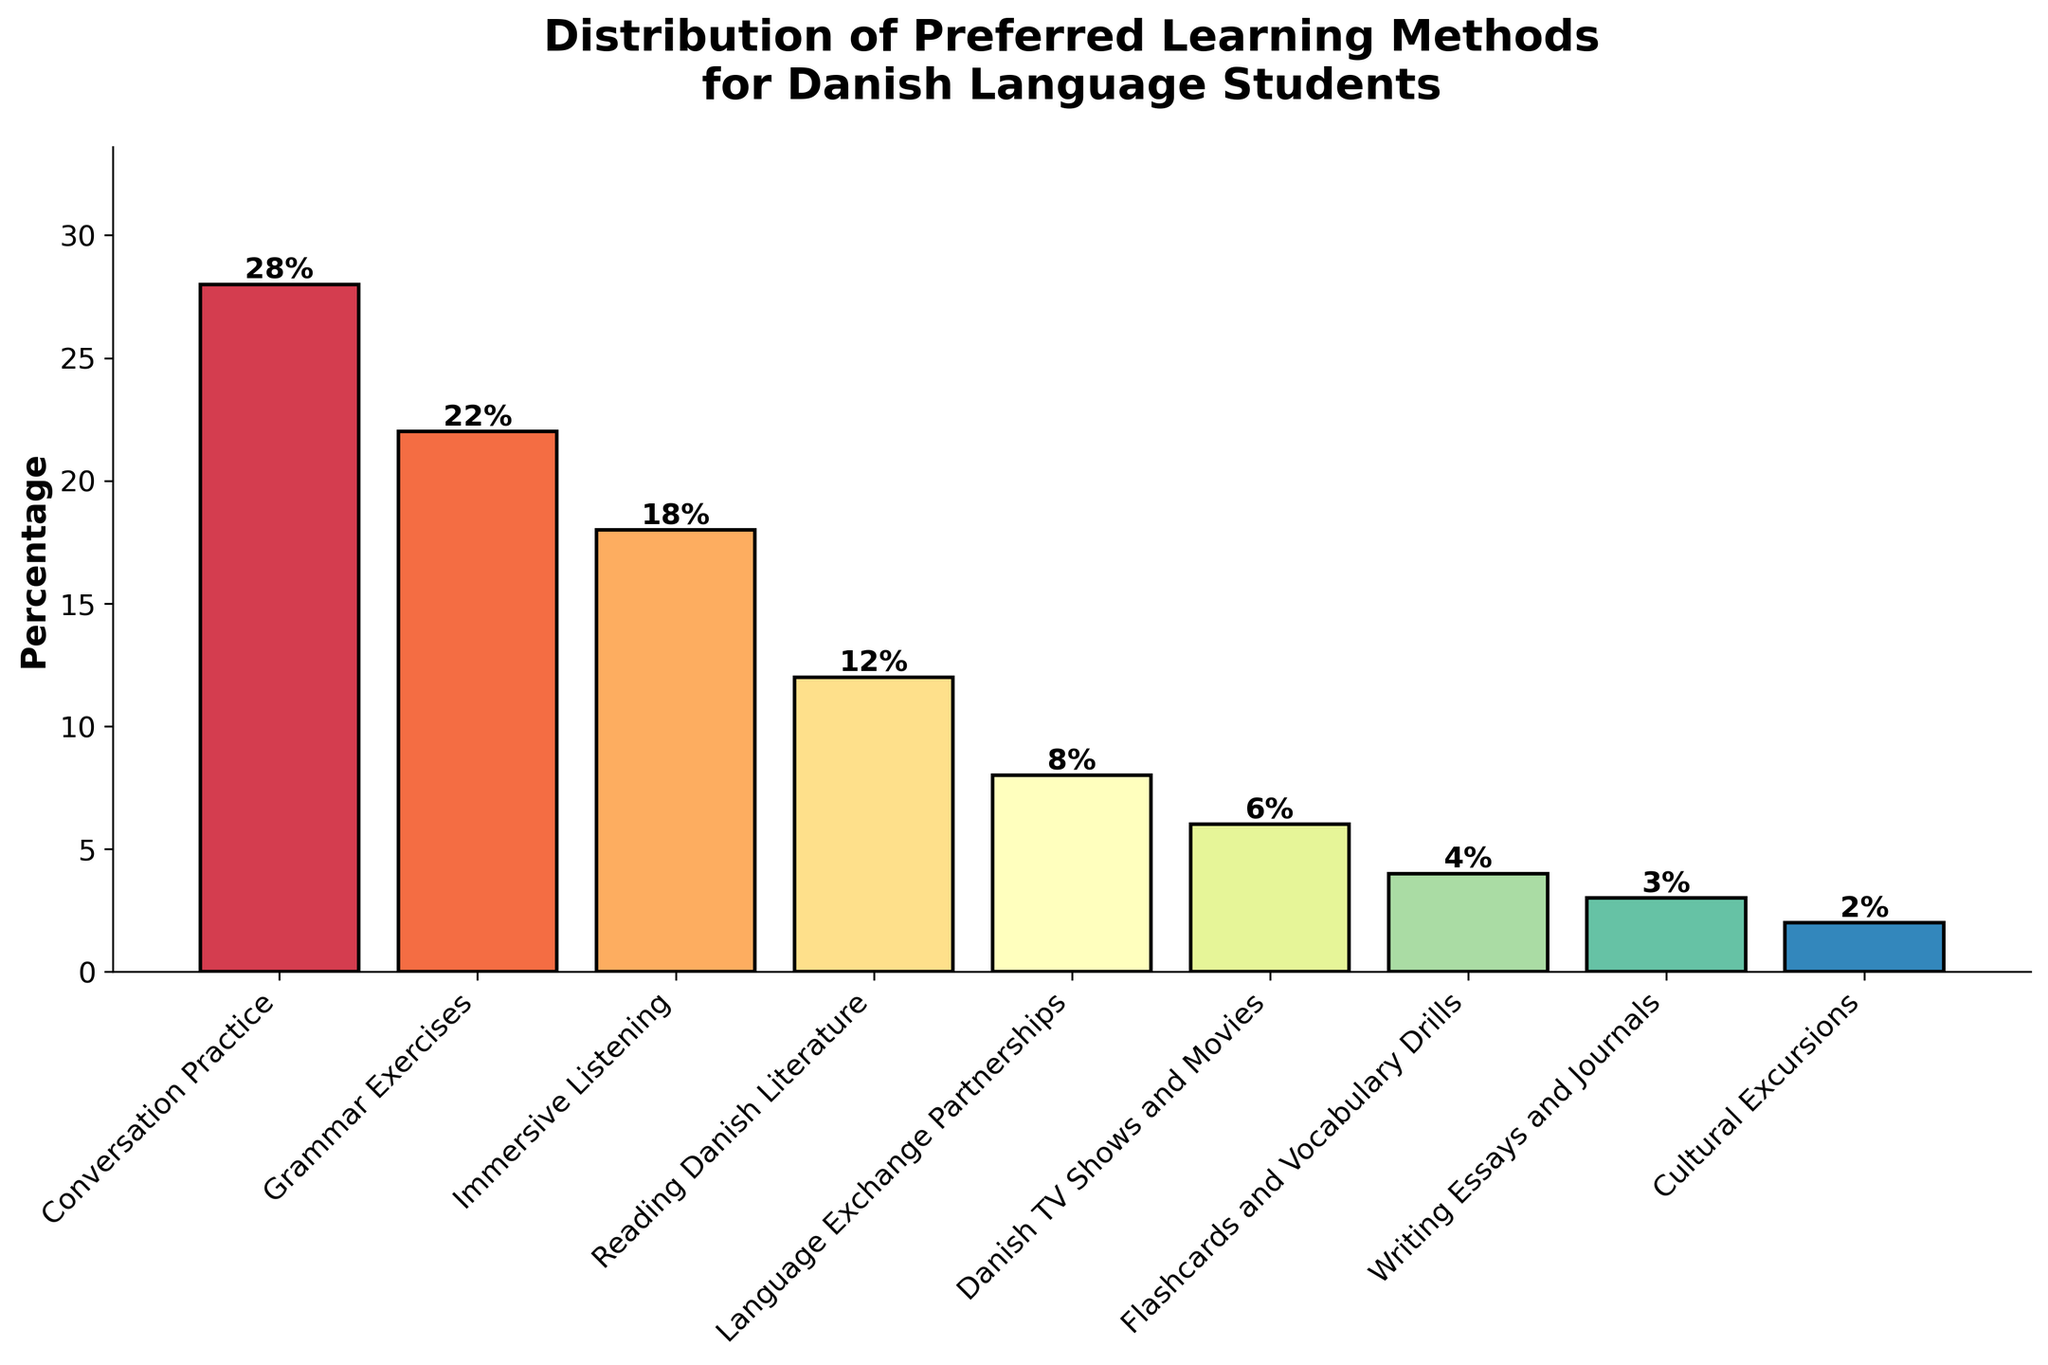Which learning method has the highest percentage? The bar for "Conversation Practice" is the tallest in the chart, indicating it has the highest percentage among all learning methods.
Answer: Conversation Practice What is the combined percentage of "Reading Danish Literature" and "Grammar Exercises"? The percentage for "Reading Danish Literature" is 12% and for "Grammar Exercises" is 22%. Adding these together: 12% + 22% = 34%.
Answer: 34% Is "Immersive Listening" more popular than "Danish TV Shows and Movies"? The percentage for "Immersive Listening" is 18%, while for "Danish TV Shows and Movies" it is 6%. Since 18% > 6%, "Immersive Listening" is more popular.
Answer: Yes What is the difference in percentage between "Conversation Practice" and "Cultural Excursions"? The percentage for "Conversation Practice" is 28% and for "Cultural Excursions" it is 2%. The difference is 28% - 2% = 26%.
Answer: 26% Which learning method has the smallest percentage? The shortest bar in the chart corresponds to "Cultural Excursions", which has the smallest percentage.
Answer: Cultural Excursions Are "Flashcards and Vocabulary Drills" more popular than "Writing Essays and Journals"? The percentage for "Flashcards and Vocabulary Drills" is 4%, while for "Writing Essays and Journals" it is 3%. Since 4% > 3%, "Flashcards and Vocabulary Drills" are more popular.
Answer: Yes How many learning methods have a percentage lower than 10%? The learning methods with percentages lower than 10% are "Language Exchange Partnerships" (8%), "Danish TV Shows and Movies" (6%), "Flashcards and Vocabulary Drills" (4%), "Writing Essays and Journals" (3%), and "Cultural Excursions" (2%). There are 5 such methods.
Answer: 5 What is the average percentage of the top three learning methods? The top three learning methods by percentage are "Conversation Practice" (28%), "Grammar Exercises" (22%), and "Immersive Listening" (18%). The average percentage is (28% + 22% + 18%) / 3 ≈ 22.67%.
Answer: 22.67% Which has a higher percentage: "Reading Danish Literature" or the combined percentages of "Writing Essays and Journals" and "Flashcards and Vocabulary Drills"? The percentage for "Reading Danish Literature" is 12%. The combined percentage for "Writing Essays and Journals" (3%) and "Flashcards and Vocabulary Drills" (4%) is 3% + 4% = 7%. Since 12% > 7%, "Reading Danish Literature" has a higher percentage.
Answer: Reading Danish Literature How much higher is the percentage for "Conversation Practice" compared to "Grammar Exercises"? The percentage for "Conversation Practice" is 28%, and for "Grammar Exercises" it is 22%. The difference is 28% - 22% = 6%.
Answer: 6% 